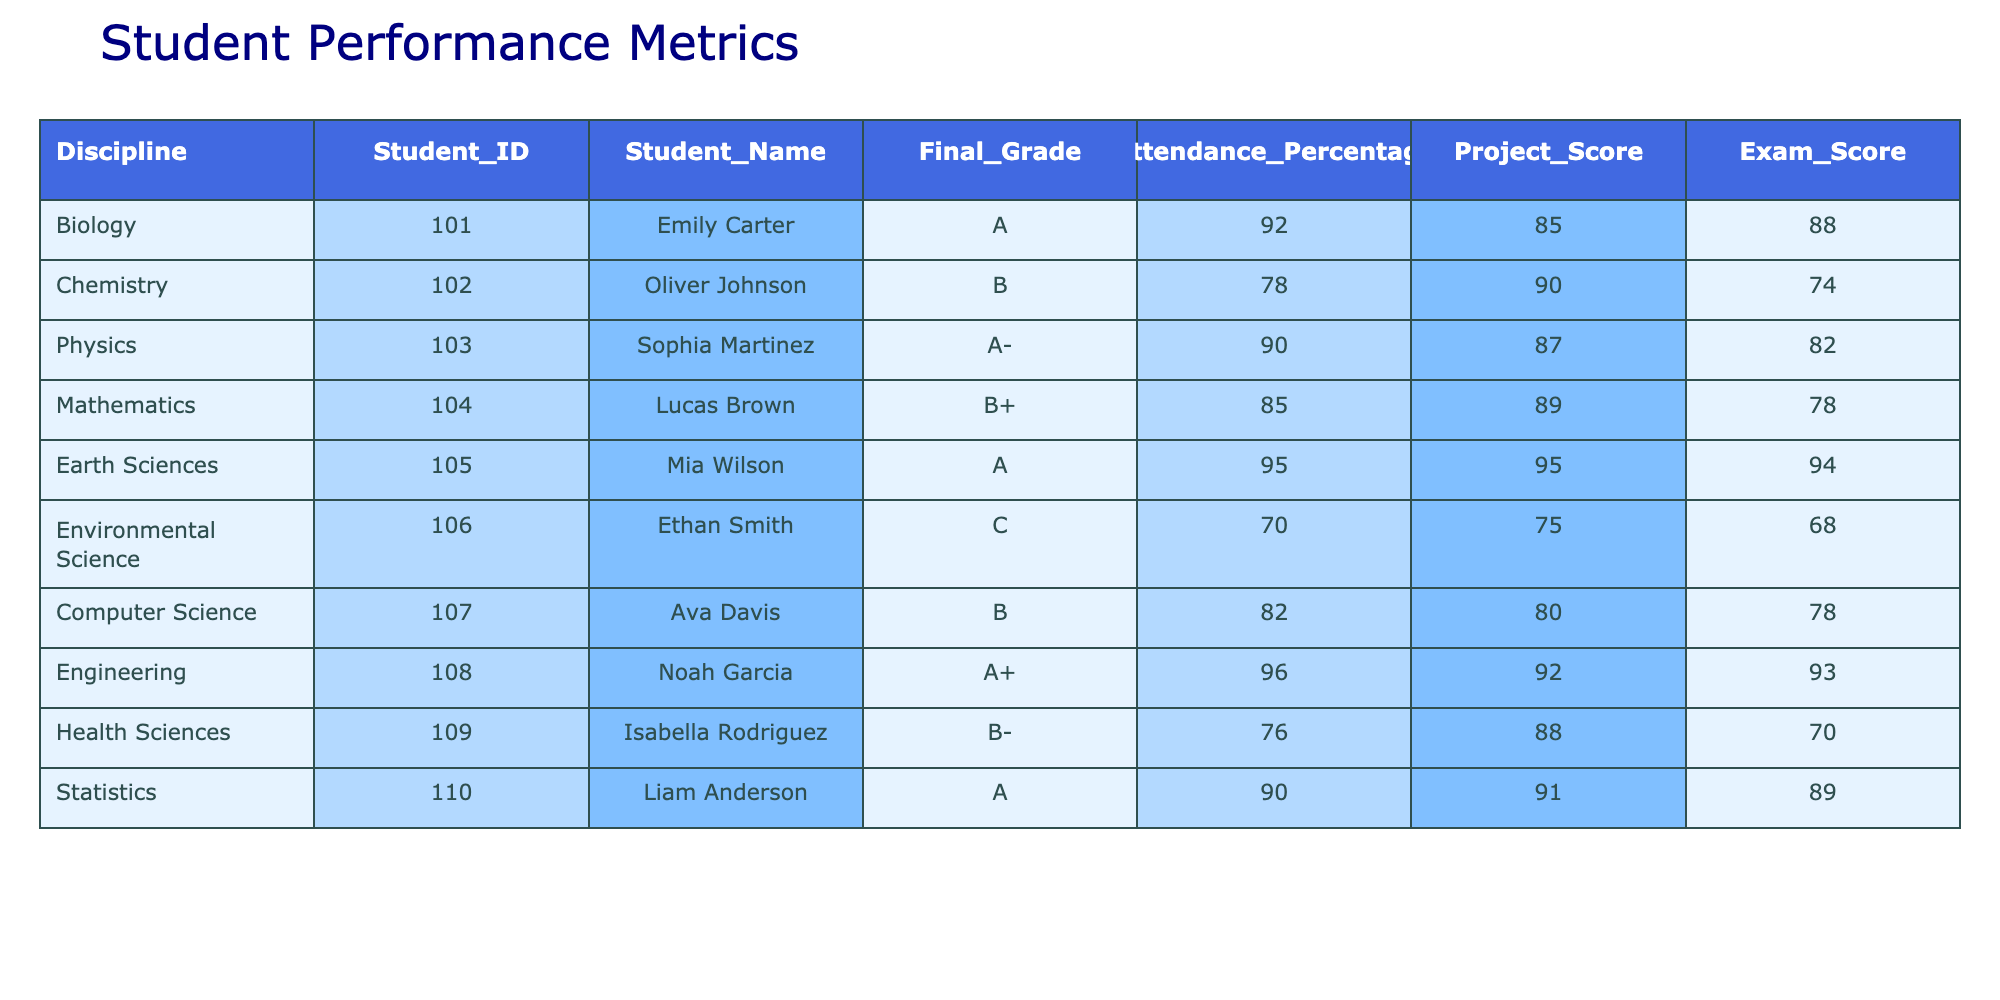What is the final grade of Ava Davis? According to the table, Ava Davis is listed under the Computer Science discipline, and her final grade is indicated as B.
Answer: B Which student has the highest attendance percentage? The attendance percentages are as follows: Emily Carter 92%, Oliver Johnson 78%, Sophia Martinez 90%, Lucas Brown 85%, Mia Wilson 95%, Ethan Smith 70%, Ava Davis 82%, Noah Garcia 96%, Isabella Rodriguez 76%, Liam Anderson 90%. The highest percentage is 96%, which belongs to Noah Garcia.
Answer: Noah Garcia Is there any student with a final grade lower than C? Reviewing the final grades, the only grade lower than C highlighted in the table is C, which belongs to Ethan Smith. Since this is not lower, there are no students with grades below C.
Answer: No What is the average exam score of students who received an A grade? Students with an A grade are Emily Carter (88), Sophia Martinez (82), Mia Wilson (94), Noah Garcia (93), and Liam Anderson (89). To calculate the average, sum the scores: 88 + 82 + 94 + 93 + 89 = 446. There are 5 students, so the average is 446/5 = 89.2.
Answer: 89.2 Which discipline has the lowest project score and what is the score? The project scores are: Biology 85, Chemistry 90, Physics 87, Mathematics 89, Earth Sciences 95, Environmental Science 75, Computer Science 80, Engineering 92, Health Sciences 88, Statistics 91. The lowest score, 75, is for Environmental Science.
Answer: Environmental Science, 75 Do any two students have the same attendance percentage? Checking the attendance percentages: Emily Carter 92%, Oliver Johnson 78%, Sophia Martinez 90%, Lucas Brown 85%, Mia Wilson 95%, Ethan Smith 70%, Ava Davis 82%, Noah Garcia 96%, Isabella Rodriguez 76%, Liam Anderson 90%. The only duplication is 90%, which belongs to both Sophia Martinez and Liam Anderson.
Answer: Yes What is the difference between the average attendance percentage of students who got A grades and those who got B grades? Students with A grades are Emily Carter (92), Sophia Martinez (90), Mia Wilson (95), Noah Garcia (96), and Liam Anderson (90). The average for A grades is (92 + 90 + 95 + 96 + 90)/5 = 92.6. Students with B grades: Oliver Johnson (78), Lucas Brown (85), Ava Davis (82), and Isabella Rodriguez (76). The average for B grades is (78 + 85 + 82 + 76)/4 = 80.25. The difference is 92.6 - 80.25 = 12.35.
Answer: 12.35 Who scored lower in exams, Ethan Smith or Isabella Rodriguez? Ethan Smith scored 68 in exams while Isabella Rodriguez scored 70. Since 68 is lower than 70, Ethan Smith scored lower.
Answer: Ethan Smith Which student has the highest final grade among the students listed? The final grades listed are A, A-, B+, B, A, C, B, A+, B-, and A. The highest grade is A+, which is awarded to Noah Garcia.
Answer: Noah Garcia 